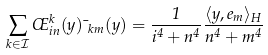<formula> <loc_0><loc_0><loc_500><loc_500>\sum _ { k \in \mathcal { I } } \phi _ { i n } ^ { k } ( y ) \mu _ { k m } ( y ) = \frac { 1 } { i ^ { 4 } + n ^ { 4 } } \frac { \langle y , e _ { m } \rangle _ { H } } { n ^ { 4 } + m ^ { 4 } }</formula> 